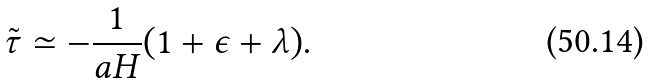Convert formula to latex. <formula><loc_0><loc_0><loc_500><loc_500>\tilde { \tau } \simeq - \frac { 1 } { a H } ( 1 + \epsilon + \lambda ) .</formula> 